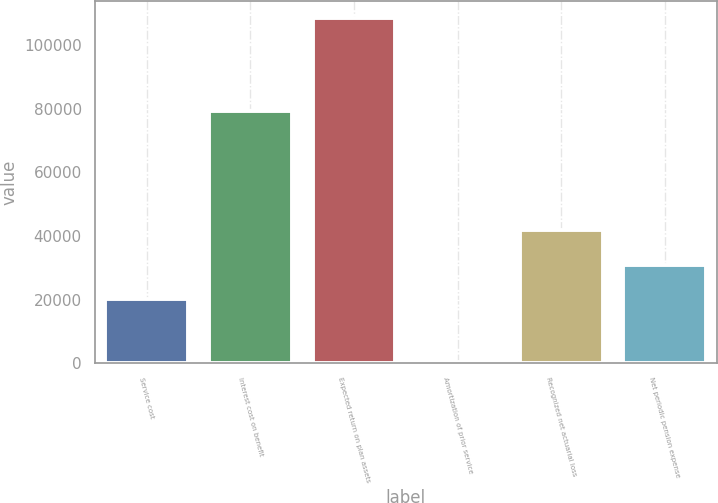<chart> <loc_0><loc_0><loc_500><loc_500><bar_chart><fcel>Service cost<fcel>Interest cost on benefit<fcel>Expected return on plan assets<fcel>Amortization of prior service<fcel>Recognized net actuarial loss<fcel>Net periodic pension expense<nl><fcel>20193<fcel>79270<fcel>108524<fcel>557<fcel>41786.4<fcel>30989.7<nl></chart> 